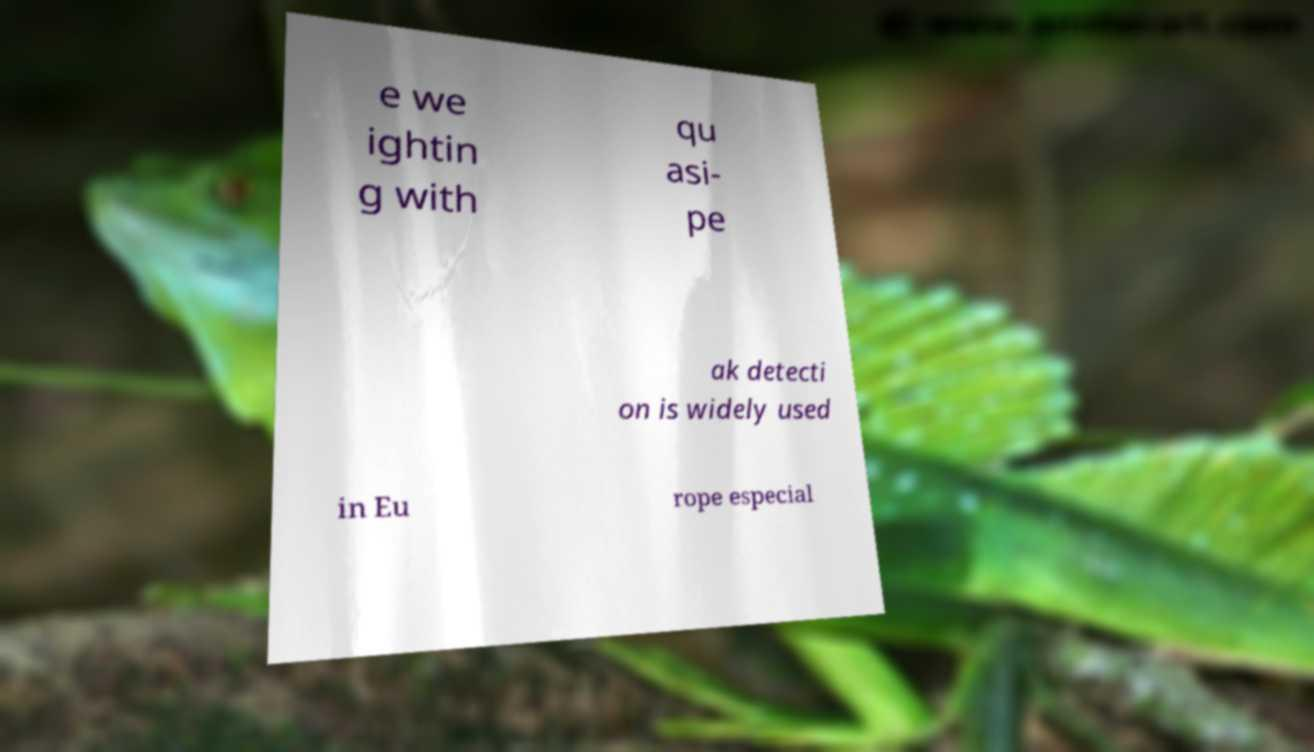What messages or text are displayed in this image? I need them in a readable, typed format. e we ightin g with qu asi- pe ak detecti on is widely used in Eu rope especial 